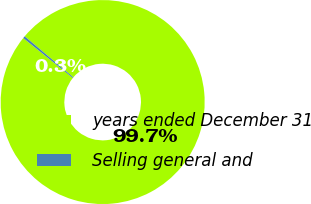Convert chart to OTSL. <chart><loc_0><loc_0><loc_500><loc_500><pie_chart><fcel>years ended December 31<fcel>Selling general and<nl><fcel>99.65%<fcel>0.35%<nl></chart> 